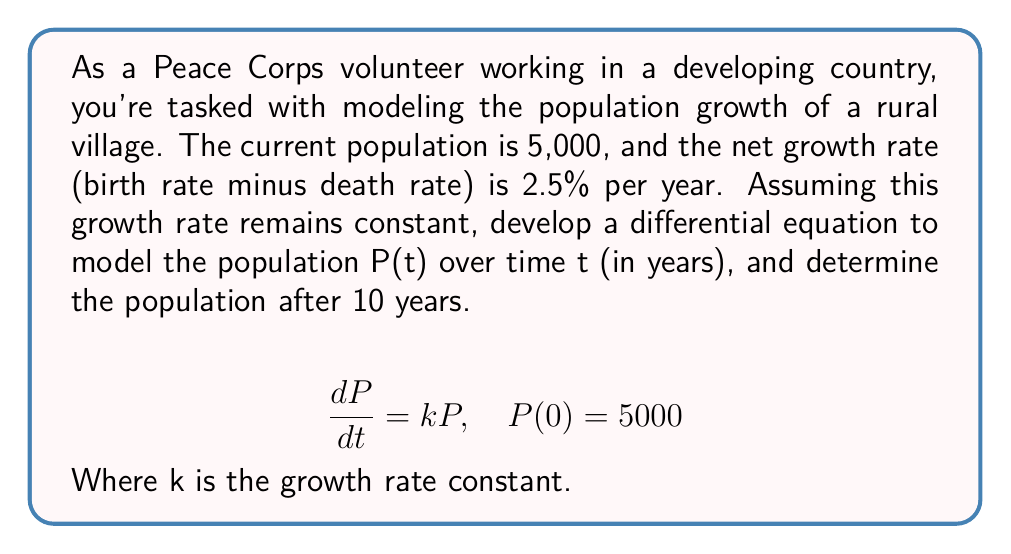Can you answer this question? 1) First, we need to identify the growth rate constant k:
   The given rate is 2.5% = 0.025 per year, so k = 0.025

2) Now our differential equation is:
   $$\frac{dP}{dt} = 0.025P, \quad P(0) = 5000$$

3) This is a separable first-order differential equation. We can solve it as follows:
   $$\frac{dP}{P} = 0.025dt$$

4) Integrating both sides:
   $$\int \frac{dP}{P} = \int 0.025dt$$
   $$\ln|P| = 0.025t + C$$

5) Solving for P:
   $$P = e^{0.025t + C} = e^C \cdot e^{0.025t}$$

6) Using the initial condition P(0) = 5000:
   $$5000 = e^C \cdot e^{0.025 \cdot 0} = e^C$$
   $$e^C = 5000$$

7) Therefore, our solution is:
   $$P(t) = 5000 \cdot e^{0.025t}$$

8) To find the population after 10 years, we calculate P(10):
   $$P(10) = 5000 \cdot e^{0.025 \cdot 10} = 5000 \cdot e^{0.25} \approx 6420$$
Answer: 6,420 people 